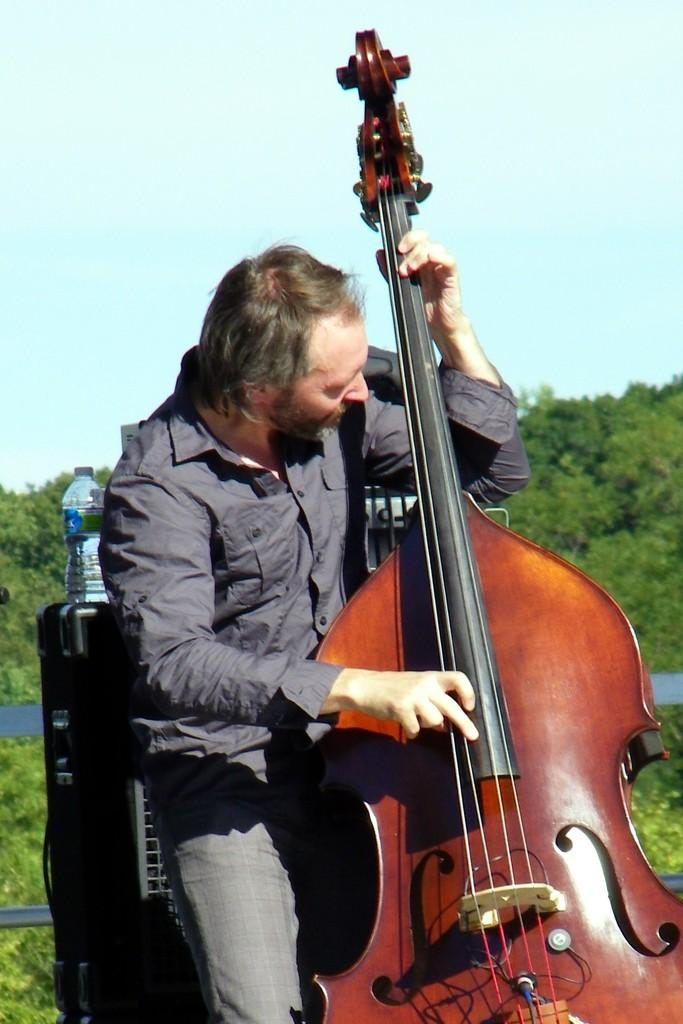What is the main subject of the image? The main subject of the image is a man. What is the man doing in the image? The man is playing the cello in the image. What type of agreement is the man signing in the image? There is no agreement present in the image; the man is playing the cello. What type of pipe is the man using to play the cello in the image? The man is playing a cello, which is a string instrument, and does not require a pipe to play. 